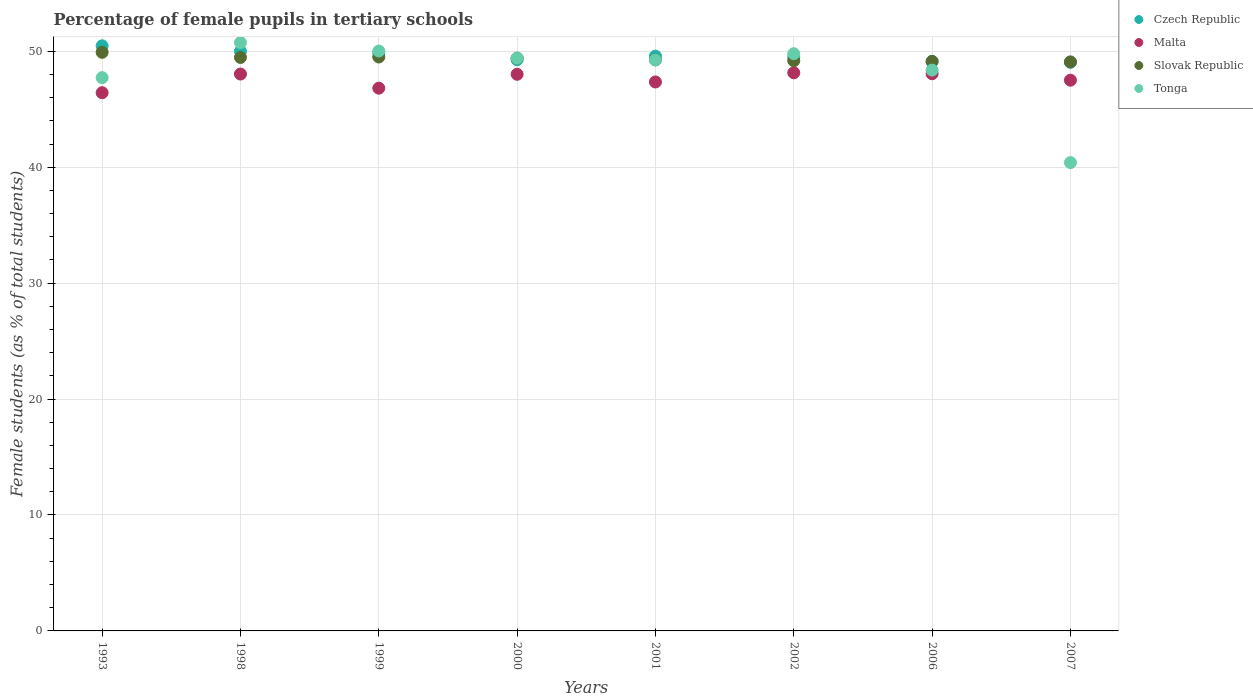How many different coloured dotlines are there?
Provide a short and direct response. 4. What is the percentage of female pupils in tertiary schools in Tonga in 1998?
Provide a short and direct response. 50.75. Across all years, what is the maximum percentage of female pupils in tertiary schools in Slovak Republic?
Keep it short and to the point. 49.91. Across all years, what is the minimum percentage of female pupils in tertiary schools in Malta?
Give a very brief answer. 46.43. In which year was the percentage of female pupils in tertiary schools in Czech Republic maximum?
Offer a very short reply. 1993. In which year was the percentage of female pupils in tertiary schools in Tonga minimum?
Ensure brevity in your answer.  2007. What is the total percentage of female pupils in tertiary schools in Czech Republic in the graph?
Your answer should be very brief. 396.87. What is the difference between the percentage of female pupils in tertiary schools in Tonga in 1999 and that in 2001?
Make the answer very short. 0.77. What is the difference between the percentage of female pupils in tertiary schools in Slovak Republic in 2006 and the percentage of female pupils in tertiary schools in Malta in 2001?
Provide a succinct answer. 1.77. What is the average percentage of female pupils in tertiary schools in Czech Republic per year?
Offer a terse response. 49.61. In the year 2002, what is the difference between the percentage of female pupils in tertiary schools in Tonga and percentage of female pupils in tertiary schools in Slovak Republic?
Provide a short and direct response. 0.6. What is the ratio of the percentage of female pupils in tertiary schools in Tonga in 1998 to that in 2001?
Offer a very short reply. 1.03. Is the difference between the percentage of female pupils in tertiary schools in Tonga in 1993 and 1998 greater than the difference between the percentage of female pupils in tertiary schools in Slovak Republic in 1993 and 1998?
Give a very brief answer. No. What is the difference between the highest and the second highest percentage of female pupils in tertiary schools in Slovak Republic?
Provide a succinct answer. 0.41. What is the difference between the highest and the lowest percentage of female pupils in tertiary schools in Czech Republic?
Offer a very short reply. 1.42. Is the sum of the percentage of female pupils in tertiary schools in Malta in 1993 and 2000 greater than the maximum percentage of female pupils in tertiary schools in Tonga across all years?
Your answer should be compact. Yes. Is it the case that in every year, the sum of the percentage of female pupils in tertiary schools in Czech Republic and percentage of female pupils in tertiary schools in Malta  is greater than the percentage of female pupils in tertiary schools in Tonga?
Offer a very short reply. Yes. Does the percentage of female pupils in tertiary schools in Czech Republic monotonically increase over the years?
Provide a short and direct response. No. Is the percentage of female pupils in tertiary schools in Slovak Republic strictly greater than the percentage of female pupils in tertiary schools in Tonga over the years?
Offer a terse response. No. Is the percentage of female pupils in tertiary schools in Czech Republic strictly less than the percentage of female pupils in tertiary schools in Malta over the years?
Offer a terse response. No. Where does the legend appear in the graph?
Provide a short and direct response. Top right. What is the title of the graph?
Provide a short and direct response. Percentage of female pupils in tertiary schools. What is the label or title of the X-axis?
Ensure brevity in your answer.  Years. What is the label or title of the Y-axis?
Keep it short and to the point. Female students (as % of total students). What is the Female students (as % of total students) of Czech Republic in 1993?
Make the answer very short. 50.47. What is the Female students (as % of total students) in Malta in 1993?
Offer a very short reply. 46.43. What is the Female students (as % of total students) in Slovak Republic in 1993?
Give a very brief answer. 49.91. What is the Female students (as % of total students) of Tonga in 1993?
Your answer should be very brief. 47.72. What is the Female students (as % of total students) in Czech Republic in 1998?
Keep it short and to the point. 50. What is the Female students (as % of total students) of Malta in 1998?
Provide a short and direct response. 48.04. What is the Female students (as % of total students) in Slovak Republic in 1998?
Offer a terse response. 49.47. What is the Female students (as % of total students) in Tonga in 1998?
Your answer should be very brief. 50.75. What is the Female students (as % of total students) of Czech Republic in 1999?
Keep it short and to the point. 49.87. What is the Female students (as % of total students) in Malta in 1999?
Give a very brief answer. 46.82. What is the Female students (as % of total students) of Slovak Republic in 1999?
Offer a terse response. 49.51. What is the Female students (as % of total students) in Tonga in 1999?
Make the answer very short. 50.02. What is the Female students (as % of total students) in Czech Republic in 2000?
Your response must be concise. 49.27. What is the Female students (as % of total students) of Malta in 2000?
Your answer should be compact. 48.02. What is the Female students (as % of total students) in Slovak Republic in 2000?
Your answer should be compact. 49.41. What is the Female students (as % of total students) of Tonga in 2000?
Keep it short and to the point. 49.41. What is the Female students (as % of total students) of Czech Republic in 2001?
Give a very brief answer. 49.58. What is the Female students (as % of total students) in Malta in 2001?
Offer a terse response. 47.35. What is the Female students (as % of total students) of Slovak Republic in 2001?
Keep it short and to the point. 49.27. What is the Female students (as % of total students) of Tonga in 2001?
Your response must be concise. 49.25. What is the Female students (as % of total students) in Czech Republic in 2002?
Offer a terse response. 49.51. What is the Female students (as % of total students) in Malta in 2002?
Provide a succinct answer. 48.15. What is the Female students (as % of total students) in Slovak Republic in 2002?
Offer a very short reply. 49.19. What is the Female students (as % of total students) of Tonga in 2002?
Offer a terse response. 49.79. What is the Female students (as % of total students) in Czech Republic in 2006?
Offer a very short reply. 49.12. What is the Female students (as % of total students) in Malta in 2006?
Your response must be concise. 48.06. What is the Female students (as % of total students) of Slovak Republic in 2006?
Give a very brief answer. 49.12. What is the Female students (as % of total students) in Tonga in 2006?
Make the answer very short. 48.38. What is the Female students (as % of total students) of Czech Republic in 2007?
Your answer should be compact. 49.05. What is the Female students (as % of total students) in Malta in 2007?
Keep it short and to the point. 47.51. What is the Female students (as % of total students) of Slovak Republic in 2007?
Provide a succinct answer. 49.08. What is the Female students (as % of total students) of Tonga in 2007?
Give a very brief answer. 40.4. Across all years, what is the maximum Female students (as % of total students) in Czech Republic?
Your answer should be very brief. 50.47. Across all years, what is the maximum Female students (as % of total students) of Malta?
Ensure brevity in your answer.  48.15. Across all years, what is the maximum Female students (as % of total students) of Slovak Republic?
Keep it short and to the point. 49.91. Across all years, what is the maximum Female students (as % of total students) in Tonga?
Your answer should be very brief. 50.75. Across all years, what is the minimum Female students (as % of total students) in Czech Republic?
Keep it short and to the point. 49.05. Across all years, what is the minimum Female students (as % of total students) in Malta?
Ensure brevity in your answer.  46.43. Across all years, what is the minimum Female students (as % of total students) of Slovak Republic?
Your response must be concise. 49.08. Across all years, what is the minimum Female students (as % of total students) in Tonga?
Ensure brevity in your answer.  40.4. What is the total Female students (as % of total students) of Czech Republic in the graph?
Keep it short and to the point. 396.87. What is the total Female students (as % of total students) of Malta in the graph?
Offer a very short reply. 380.36. What is the total Female students (as % of total students) in Slovak Republic in the graph?
Provide a succinct answer. 394.95. What is the total Female students (as % of total students) in Tonga in the graph?
Your answer should be compact. 385.72. What is the difference between the Female students (as % of total students) in Czech Republic in 1993 and that in 1998?
Keep it short and to the point. 0.47. What is the difference between the Female students (as % of total students) in Malta in 1993 and that in 1998?
Ensure brevity in your answer.  -1.61. What is the difference between the Female students (as % of total students) in Slovak Republic in 1993 and that in 1998?
Offer a very short reply. 0.44. What is the difference between the Female students (as % of total students) of Tonga in 1993 and that in 1998?
Offer a terse response. -3.03. What is the difference between the Female students (as % of total students) in Czech Republic in 1993 and that in 1999?
Give a very brief answer. 0.6. What is the difference between the Female students (as % of total students) of Malta in 1993 and that in 1999?
Ensure brevity in your answer.  -0.39. What is the difference between the Female students (as % of total students) of Slovak Republic in 1993 and that in 1999?
Ensure brevity in your answer.  0.41. What is the difference between the Female students (as % of total students) in Tonga in 1993 and that in 1999?
Provide a succinct answer. -2.3. What is the difference between the Female students (as % of total students) of Czech Republic in 1993 and that in 2000?
Provide a succinct answer. 1.2. What is the difference between the Female students (as % of total students) in Malta in 1993 and that in 2000?
Your response must be concise. -1.59. What is the difference between the Female students (as % of total students) of Slovak Republic in 1993 and that in 2000?
Ensure brevity in your answer.  0.5. What is the difference between the Female students (as % of total students) in Tonga in 1993 and that in 2000?
Provide a succinct answer. -1.68. What is the difference between the Female students (as % of total students) of Czech Republic in 1993 and that in 2001?
Your answer should be compact. 0.89. What is the difference between the Female students (as % of total students) in Malta in 1993 and that in 2001?
Keep it short and to the point. -0.93. What is the difference between the Female students (as % of total students) in Slovak Republic in 1993 and that in 2001?
Your answer should be very brief. 0.64. What is the difference between the Female students (as % of total students) in Tonga in 1993 and that in 2001?
Your answer should be very brief. -1.52. What is the difference between the Female students (as % of total students) in Czech Republic in 1993 and that in 2002?
Make the answer very short. 0.97. What is the difference between the Female students (as % of total students) in Malta in 1993 and that in 2002?
Your answer should be very brief. -1.72. What is the difference between the Female students (as % of total students) of Slovak Republic in 1993 and that in 2002?
Your answer should be very brief. 0.72. What is the difference between the Female students (as % of total students) of Tonga in 1993 and that in 2002?
Give a very brief answer. -2.07. What is the difference between the Female students (as % of total students) of Czech Republic in 1993 and that in 2006?
Give a very brief answer. 1.35. What is the difference between the Female students (as % of total students) in Malta in 1993 and that in 2006?
Make the answer very short. -1.64. What is the difference between the Female students (as % of total students) of Slovak Republic in 1993 and that in 2006?
Your answer should be very brief. 0.79. What is the difference between the Female students (as % of total students) in Tonga in 1993 and that in 2006?
Your response must be concise. -0.65. What is the difference between the Female students (as % of total students) of Czech Republic in 1993 and that in 2007?
Give a very brief answer. 1.42. What is the difference between the Female students (as % of total students) in Malta in 1993 and that in 2007?
Ensure brevity in your answer.  -1.08. What is the difference between the Female students (as % of total students) of Slovak Republic in 1993 and that in 2007?
Offer a very short reply. 0.83. What is the difference between the Female students (as % of total students) of Tonga in 1993 and that in 2007?
Offer a very short reply. 7.33. What is the difference between the Female students (as % of total students) of Czech Republic in 1998 and that in 1999?
Your answer should be compact. 0.13. What is the difference between the Female students (as % of total students) of Malta in 1998 and that in 1999?
Your response must be concise. 1.22. What is the difference between the Female students (as % of total students) in Slovak Republic in 1998 and that in 1999?
Keep it short and to the point. -0.04. What is the difference between the Female students (as % of total students) in Tonga in 1998 and that in 1999?
Your answer should be compact. 0.73. What is the difference between the Female students (as % of total students) of Czech Republic in 1998 and that in 2000?
Offer a terse response. 0.72. What is the difference between the Female students (as % of total students) of Malta in 1998 and that in 2000?
Give a very brief answer. 0.02. What is the difference between the Female students (as % of total students) of Slovak Republic in 1998 and that in 2000?
Your answer should be compact. 0.06. What is the difference between the Female students (as % of total students) in Tonga in 1998 and that in 2000?
Provide a succinct answer. 1.34. What is the difference between the Female students (as % of total students) of Czech Republic in 1998 and that in 2001?
Offer a very short reply. 0.42. What is the difference between the Female students (as % of total students) of Malta in 1998 and that in 2001?
Provide a short and direct response. 0.68. What is the difference between the Female students (as % of total students) of Slovak Republic in 1998 and that in 2001?
Offer a terse response. 0.2. What is the difference between the Female students (as % of total students) of Tonga in 1998 and that in 2001?
Provide a succinct answer. 1.5. What is the difference between the Female students (as % of total students) in Czech Republic in 1998 and that in 2002?
Give a very brief answer. 0.49. What is the difference between the Female students (as % of total students) of Malta in 1998 and that in 2002?
Ensure brevity in your answer.  -0.11. What is the difference between the Female students (as % of total students) of Slovak Republic in 1998 and that in 2002?
Keep it short and to the point. 0.28. What is the difference between the Female students (as % of total students) of Tonga in 1998 and that in 2002?
Offer a very short reply. 0.96. What is the difference between the Female students (as % of total students) of Czech Republic in 1998 and that in 2006?
Give a very brief answer. 0.87. What is the difference between the Female students (as % of total students) of Malta in 1998 and that in 2006?
Offer a very short reply. -0.03. What is the difference between the Female students (as % of total students) in Slovak Republic in 1998 and that in 2006?
Ensure brevity in your answer.  0.34. What is the difference between the Female students (as % of total students) in Tonga in 1998 and that in 2006?
Keep it short and to the point. 2.37. What is the difference between the Female students (as % of total students) of Czech Republic in 1998 and that in 2007?
Ensure brevity in your answer.  0.95. What is the difference between the Female students (as % of total students) in Malta in 1998 and that in 2007?
Make the answer very short. 0.53. What is the difference between the Female students (as % of total students) in Slovak Republic in 1998 and that in 2007?
Offer a very short reply. 0.38. What is the difference between the Female students (as % of total students) in Tonga in 1998 and that in 2007?
Your answer should be compact. 10.35. What is the difference between the Female students (as % of total students) in Czech Republic in 1999 and that in 2000?
Your answer should be compact. 0.59. What is the difference between the Female students (as % of total students) in Malta in 1999 and that in 2000?
Keep it short and to the point. -1.2. What is the difference between the Female students (as % of total students) of Slovak Republic in 1999 and that in 2000?
Make the answer very short. 0.1. What is the difference between the Female students (as % of total students) in Tonga in 1999 and that in 2000?
Offer a terse response. 0.61. What is the difference between the Female students (as % of total students) of Czech Republic in 1999 and that in 2001?
Offer a terse response. 0.29. What is the difference between the Female students (as % of total students) in Malta in 1999 and that in 2001?
Provide a short and direct response. -0.54. What is the difference between the Female students (as % of total students) in Slovak Republic in 1999 and that in 2001?
Keep it short and to the point. 0.24. What is the difference between the Female students (as % of total students) in Tonga in 1999 and that in 2001?
Ensure brevity in your answer.  0.77. What is the difference between the Female students (as % of total students) in Czech Republic in 1999 and that in 2002?
Your response must be concise. 0.36. What is the difference between the Female students (as % of total students) of Malta in 1999 and that in 2002?
Ensure brevity in your answer.  -1.33. What is the difference between the Female students (as % of total students) in Slovak Republic in 1999 and that in 2002?
Keep it short and to the point. 0.32. What is the difference between the Female students (as % of total students) of Tonga in 1999 and that in 2002?
Your response must be concise. 0.23. What is the difference between the Female students (as % of total students) in Czech Republic in 1999 and that in 2006?
Your answer should be compact. 0.74. What is the difference between the Female students (as % of total students) in Malta in 1999 and that in 2006?
Give a very brief answer. -1.24. What is the difference between the Female students (as % of total students) in Slovak Republic in 1999 and that in 2006?
Offer a terse response. 0.38. What is the difference between the Female students (as % of total students) of Tonga in 1999 and that in 2006?
Your answer should be compact. 1.64. What is the difference between the Female students (as % of total students) of Czech Republic in 1999 and that in 2007?
Provide a succinct answer. 0.82. What is the difference between the Female students (as % of total students) of Malta in 1999 and that in 2007?
Make the answer very short. -0.69. What is the difference between the Female students (as % of total students) in Slovak Republic in 1999 and that in 2007?
Your answer should be compact. 0.42. What is the difference between the Female students (as % of total students) of Tonga in 1999 and that in 2007?
Offer a very short reply. 9.62. What is the difference between the Female students (as % of total students) in Czech Republic in 2000 and that in 2001?
Make the answer very short. -0.31. What is the difference between the Female students (as % of total students) in Malta in 2000 and that in 2001?
Offer a very short reply. 0.66. What is the difference between the Female students (as % of total students) of Slovak Republic in 2000 and that in 2001?
Offer a very short reply. 0.14. What is the difference between the Female students (as % of total students) of Tonga in 2000 and that in 2001?
Your answer should be very brief. 0.16. What is the difference between the Female students (as % of total students) of Czech Republic in 2000 and that in 2002?
Your answer should be compact. -0.23. What is the difference between the Female students (as % of total students) of Malta in 2000 and that in 2002?
Your answer should be compact. -0.13. What is the difference between the Female students (as % of total students) of Slovak Republic in 2000 and that in 2002?
Your answer should be very brief. 0.22. What is the difference between the Female students (as % of total students) in Tonga in 2000 and that in 2002?
Offer a very short reply. -0.38. What is the difference between the Female students (as % of total students) in Czech Republic in 2000 and that in 2006?
Keep it short and to the point. 0.15. What is the difference between the Female students (as % of total students) of Malta in 2000 and that in 2006?
Keep it short and to the point. -0.05. What is the difference between the Female students (as % of total students) in Slovak Republic in 2000 and that in 2006?
Make the answer very short. 0.28. What is the difference between the Female students (as % of total students) in Tonga in 2000 and that in 2006?
Provide a succinct answer. 1.03. What is the difference between the Female students (as % of total students) in Czech Republic in 2000 and that in 2007?
Offer a terse response. 0.22. What is the difference between the Female students (as % of total students) of Malta in 2000 and that in 2007?
Make the answer very short. 0.51. What is the difference between the Female students (as % of total students) of Slovak Republic in 2000 and that in 2007?
Ensure brevity in your answer.  0.32. What is the difference between the Female students (as % of total students) of Tonga in 2000 and that in 2007?
Make the answer very short. 9.01. What is the difference between the Female students (as % of total students) in Czech Republic in 2001 and that in 2002?
Give a very brief answer. 0.08. What is the difference between the Female students (as % of total students) of Malta in 2001 and that in 2002?
Give a very brief answer. -0.79. What is the difference between the Female students (as % of total students) in Slovak Republic in 2001 and that in 2002?
Offer a terse response. 0.08. What is the difference between the Female students (as % of total students) of Tonga in 2001 and that in 2002?
Your answer should be very brief. -0.54. What is the difference between the Female students (as % of total students) in Czech Republic in 2001 and that in 2006?
Make the answer very short. 0.46. What is the difference between the Female students (as % of total students) in Malta in 2001 and that in 2006?
Keep it short and to the point. -0.71. What is the difference between the Female students (as % of total students) in Slovak Republic in 2001 and that in 2006?
Offer a terse response. 0.14. What is the difference between the Female students (as % of total students) of Tonga in 2001 and that in 2006?
Keep it short and to the point. 0.87. What is the difference between the Female students (as % of total students) of Czech Republic in 2001 and that in 2007?
Your response must be concise. 0.53. What is the difference between the Female students (as % of total students) of Malta in 2001 and that in 2007?
Your answer should be very brief. -0.15. What is the difference between the Female students (as % of total students) in Slovak Republic in 2001 and that in 2007?
Your answer should be compact. 0.18. What is the difference between the Female students (as % of total students) of Tonga in 2001 and that in 2007?
Keep it short and to the point. 8.85. What is the difference between the Female students (as % of total students) in Czech Republic in 2002 and that in 2006?
Ensure brevity in your answer.  0.38. What is the difference between the Female students (as % of total students) in Malta in 2002 and that in 2006?
Your response must be concise. 0.09. What is the difference between the Female students (as % of total students) in Slovak Republic in 2002 and that in 2006?
Provide a succinct answer. 0.06. What is the difference between the Female students (as % of total students) of Tonga in 2002 and that in 2006?
Ensure brevity in your answer.  1.41. What is the difference between the Female students (as % of total students) in Czech Republic in 2002 and that in 2007?
Offer a very short reply. 0.45. What is the difference between the Female students (as % of total students) of Malta in 2002 and that in 2007?
Give a very brief answer. 0.64. What is the difference between the Female students (as % of total students) in Slovak Republic in 2002 and that in 2007?
Give a very brief answer. 0.1. What is the difference between the Female students (as % of total students) in Tonga in 2002 and that in 2007?
Your response must be concise. 9.39. What is the difference between the Female students (as % of total students) of Czech Republic in 2006 and that in 2007?
Make the answer very short. 0.07. What is the difference between the Female students (as % of total students) in Malta in 2006 and that in 2007?
Provide a short and direct response. 0.56. What is the difference between the Female students (as % of total students) of Slovak Republic in 2006 and that in 2007?
Your answer should be compact. 0.04. What is the difference between the Female students (as % of total students) in Tonga in 2006 and that in 2007?
Keep it short and to the point. 7.98. What is the difference between the Female students (as % of total students) of Czech Republic in 1993 and the Female students (as % of total students) of Malta in 1998?
Give a very brief answer. 2.44. What is the difference between the Female students (as % of total students) of Czech Republic in 1993 and the Female students (as % of total students) of Slovak Republic in 1998?
Provide a short and direct response. 1. What is the difference between the Female students (as % of total students) in Czech Republic in 1993 and the Female students (as % of total students) in Tonga in 1998?
Provide a short and direct response. -0.28. What is the difference between the Female students (as % of total students) of Malta in 1993 and the Female students (as % of total students) of Slovak Republic in 1998?
Ensure brevity in your answer.  -3.04. What is the difference between the Female students (as % of total students) of Malta in 1993 and the Female students (as % of total students) of Tonga in 1998?
Offer a very short reply. -4.32. What is the difference between the Female students (as % of total students) of Slovak Republic in 1993 and the Female students (as % of total students) of Tonga in 1998?
Your answer should be very brief. -0.84. What is the difference between the Female students (as % of total students) in Czech Republic in 1993 and the Female students (as % of total students) in Malta in 1999?
Keep it short and to the point. 3.65. What is the difference between the Female students (as % of total students) in Czech Republic in 1993 and the Female students (as % of total students) in Slovak Republic in 1999?
Make the answer very short. 0.97. What is the difference between the Female students (as % of total students) in Czech Republic in 1993 and the Female students (as % of total students) in Tonga in 1999?
Your answer should be compact. 0.45. What is the difference between the Female students (as % of total students) of Malta in 1993 and the Female students (as % of total students) of Slovak Republic in 1999?
Give a very brief answer. -3.08. What is the difference between the Female students (as % of total students) in Malta in 1993 and the Female students (as % of total students) in Tonga in 1999?
Give a very brief answer. -3.6. What is the difference between the Female students (as % of total students) in Slovak Republic in 1993 and the Female students (as % of total students) in Tonga in 1999?
Make the answer very short. -0.11. What is the difference between the Female students (as % of total students) in Czech Republic in 1993 and the Female students (as % of total students) in Malta in 2000?
Make the answer very short. 2.46. What is the difference between the Female students (as % of total students) of Czech Republic in 1993 and the Female students (as % of total students) of Slovak Republic in 2000?
Provide a succinct answer. 1.06. What is the difference between the Female students (as % of total students) of Czech Republic in 1993 and the Female students (as % of total students) of Tonga in 2000?
Your answer should be very brief. 1.06. What is the difference between the Female students (as % of total students) of Malta in 1993 and the Female students (as % of total students) of Slovak Republic in 2000?
Provide a short and direct response. -2.98. What is the difference between the Female students (as % of total students) of Malta in 1993 and the Female students (as % of total students) of Tonga in 2000?
Your response must be concise. -2.98. What is the difference between the Female students (as % of total students) in Slovak Republic in 1993 and the Female students (as % of total students) in Tonga in 2000?
Offer a very short reply. 0.5. What is the difference between the Female students (as % of total students) of Czech Republic in 1993 and the Female students (as % of total students) of Malta in 2001?
Your response must be concise. 3.12. What is the difference between the Female students (as % of total students) in Czech Republic in 1993 and the Female students (as % of total students) in Slovak Republic in 2001?
Your response must be concise. 1.2. What is the difference between the Female students (as % of total students) in Czech Republic in 1993 and the Female students (as % of total students) in Tonga in 2001?
Provide a short and direct response. 1.22. What is the difference between the Female students (as % of total students) in Malta in 1993 and the Female students (as % of total students) in Slovak Republic in 2001?
Offer a terse response. -2.84. What is the difference between the Female students (as % of total students) in Malta in 1993 and the Female students (as % of total students) in Tonga in 2001?
Give a very brief answer. -2.82. What is the difference between the Female students (as % of total students) in Slovak Republic in 1993 and the Female students (as % of total students) in Tonga in 2001?
Make the answer very short. 0.66. What is the difference between the Female students (as % of total students) of Czech Republic in 1993 and the Female students (as % of total students) of Malta in 2002?
Give a very brief answer. 2.33. What is the difference between the Female students (as % of total students) of Czech Republic in 1993 and the Female students (as % of total students) of Slovak Republic in 2002?
Provide a short and direct response. 1.28. What is the difference between the Female students (as % of total students) in Czech Republic in 1993 and the Female students (as % of total students) in Tonga in 2002?
Give a very brief answer. 0.68. What is the difference between the Female students (as % of total students) in Malta in 1993 and the Female students (as % of total students) in Slovak Republic in 2002?
Keep it short and to the point. -2.76. What is the difference between the Female students (as % of total students) of Malta in 1993 and the Female students (as % of total students) of Tonga in 2002?
Keep it short and to the point. -3.37. What is the difference between the Female students (as % of total students) in Slovak Republic in 1993 and the Female students (as % of total students) in Tonga in 2002?
Your response must be concise. 0.12. What is the difference between the Female students (as % of total students) of Czech Republic in 1993 and the Female students (as % of total students) of Malta in 2006?
Your answer should be compact. 2.41. What is the difference between the Female students (as % of total students) of Czech Republic in 1993 and the Female students (as % of total students) of Slovak Republic in 2006?
Provide a short and direct response. 1.35. What is the difference between the Female students (as % of total students) in Czech Republic in 1993 and the Female students (as % of total students) in Tonga in 2006?
Ensure brevity in your answer.  2.09. What is the difference between the Female students (as % of total students) of Malta in 1993 and the Female students (as % of total students) of Slovak Republic in 2006?
Your answer should be compact. -2.7. What is the difference between the Female students (as % of total students) of Malta in 1993 and the Female students (as % of total students) of Tonga in 2006?
Provide a succinct answer. -1.95. What is the difference between the Female students (as % of total students) of Slovak Republic in 1993 and the Female students (as % of total students) of Tonga in 2006?
Provide a short and direct response. 1.53. What is the difference between the Female students (as % of total students) of Czech Republic in 1993 and the Female students (as % of total students) of Malta in 2007?
Offer a terse response. 2.97. What is the difference between the Female students (as % of total students) of Czech Republic in 1993 and the Female students (as % of total students) of Slovak Republic in 2007?
Your response must be concise. 1.39. What is the difference between the Female students (as % of total students) in Czech Republic in 1993 and the Female students (as % of total students) in Tonga in 2007?
Keep it short and to the point. 10.07. What is the difference between the Female students (as % of total students) of Malta in 1993 and the Female students (as % of total students) of Slovak Republic in 2007?
Offer a very short reply. -2.66. What is the difference between the Female students (as % of total students) of Malta in 1993 and the Female students (as % of total students) of Tonga in 2007?
Make the answer very short. 6.03. What is the difference between the Female students (as % of total students) in Slovak Republic in 1993 and the Female students (as % of total students) in Tonga in 2007?
Offer a very short reply. 9.51. What is the difference between the Female students (as % of total students) in Czech Republic in 1998 and the Female students (as % of total students) in Malta in 1999?
Give a very brief answer. 3.18. What is the difference between the Female students (as % of total students) in Czech Republic in 1998 and the Female students (as % of total students) in Slovak Republic in 1999?
Your answer should be compact. 0.49. What is the difference between the Female students (as % of total students) in Czech Republic in 1998 and the Female students (as % of total students) in Tonga in 1999?
Your response must be concise. -0.02. What is the difference between the Female students (as % of total students) in Malta in 1998 and the Female students (as % of total students) in Slovak Republic in 1999?
Ensure brevity in your answer.  -1.47. What is the difference between the Female students (as % of total students) of Malta in 1998 and the Female students (as % of total students) of Tonga in 1999?
Offer a very short reply. -1.99. What is the difference between the Female students (as % of total students) of Slovak Republic in 1998 and the Female students (as % of total students) of Tonga in 1999?
Offer a very short reply. -0.55. What is the difference between the Female students (as % of total students) of Czech Republic in 1998 and the Female students (as % of total students) of Malta in 2000?
Give a very brief answer. 1.98. What is the difference between the Female students (as % of total students) in Czech Republic in 1998 and the Female students (as % of total students) in Slovak Republic in 2000?
Your answer should be compact. 0.59. What is the difference between the Female students (as % of total students) of Czech Republic in 1998 and the Female students (as % of total students) of Tonga in 2000?
Your answer should be very brief. 0.59. What is the difference between the Female students (as % of total students) in Malta in 1998 and the Female students (as % of total students) in Slovak Republic in 2000?
Provide a succinct answer. -1.37. What is the difference between the Female students (as % of total students) in Malta in 1998 and the Female students (as % of total students) in Tonga in 2000?
Make the answer very short. -1.37. What is the difference between the Female students (as % of total students) in Slovak Republic in 1998 and the Female students (as % of total students) in Tonga in 2000?
Offer a terse response. 0.06. What is the difference between the Female students (as % of total students) in Czech Republic in 1998 and the Female students (as % of total students) in Malta in 2001?
Your response must be concise. 2.64. What is the difference between the Female students (as % of total students) of Czech Republic in 1998 and the Female students (as % of total students) of Slovak Republic in 2001?
Your response must be concise. 0.73. What is the difference between the Female students (as % of total students) of Czech Republic in 1998 and the Female students (as % of total students) of Tonga in 2001?
Your response must be concise. 0.75. What is the difference between the Female students (as % of total students) in Malta in 1998 and the Female students (as % of total students) in Slovak Republic in 2001?
Ensure brevity in your answer.  -1.23. What is the difference between the Female students (as % of total students) of Malta in 1998 and the Female students (as % of total students) of Tonga in 2001?
Ensure brevity in your answer.  -1.21. What is the difference between the Female students (as % of total students) of Slovak Republic in 1998 and the Female students (as % of total students) of Tonga in 2001?
Your response must be concise. 0.22. What is the difference between the Female students (as % of total students) of Czech Republic in 1998 and the Female students (as % of total students) of Malta in 2002?
Ensure brevity in your answer.  1.85. What is the difference between the Female students (as % of total students) in Czech Republic in 1998 and the Female students (as % of total students) in Slovak Republic in 2002?
Keep it short and to the point. 0.81. What is the difference between the Female students (as % of total students) of Czech Republic in 1998 and the Female students (as % of total students) of Tonga in 2002?
Your answer should be very brief. 0.21. What is the difference between the Female students (as % of total students) of Malta in 1998 and the Female students (as % of total students) of Slovak Republic in 2002?
Your answer should be compact. -1.15. What is the difference between the Female students (as % of total students) of Malta in 1998 and the Female students (as % of total students) of Tonga in 2002?
Provide a short and direct response. -1.76. What is the difference between the Female students (as % of total students) of Slovak Republic in 1998 and the Female students (as % of total students) of Tonga in 2002?
Your response must be concise. -0.32. What is the difference between the Female students (as % of total students) in Czech Republic in 1998 and the Female students (as % of total students) in Malta in 2006?
Your answer should be compact. 1.94. What is the difference between the Female students (as % of total students) in Czech Republic in 1998 and the Female students (as % of total students) in Slovak Republic in 2006?
Provide a succinct answer. 0.87. What is the difference between the Female students (as % of total students) in Czech Republic in 1998 and the Female students (as % of total students) in Tonga in 2006?
Offer a very short reply. 1.62. What is the difference between the Female students (as % of total students) in Malta in 1998 and the Female students (as % of total students) in Slovak Republic in 2006?
Your answer should be very brief. -1.09. What is the difference between the Female students (as % of total students) of Malta in 1998 and the Female students (as % of total students) of Tonga in 2006?
Provide a short and direct response. -0.34. What is the difference between the Female students (as % of total students) of Slovak Republic in 1998 and the Female students (as % of total students) of Tonga in 2006?
Ensure brevity in your answer.  1.09. What is the difference between the Female students (as % of total students) of Czech Republic in 1998 and the Female students (as % of total students) of Malta in 2007?
Keep it short and to the point. 2.49. What is the difference between the Female students (as % of total students) in Czech Republic in 1998 and the Female students (as % of total students) in Slovak Republic in 2007?
Your response must be concise. 0.91. What is the difference between the Female students (as % of total students) of Czech Republic in 1998 and the Female students (as % of total students) of Tonga in 2007?
Make the answer very short. 9.6. What is the difference between the Female students (as % of total students) of Malta in 1998 and the Female students (as % of total students) of Slovak Republic in 2007?
Provide a short and direct response. -1.05. What is the difference between the Female students (as % of total students) of Malta in 1998 and the Female students (as % of total students) of Tonga in 2007?
Provide a short and direct response. 7.64. What is the difference between the Female students (as % of total students) of Slovak Republic in 1998 and the Female students (as % of total students) of Tonga in 2007?
Provide a short and direct response. 9.07. What is the difference between the Female students (as % of total students) in Czech Republic in 1999 and the Female students (as % of total students) in Malta in 2000?
Offer a terse response. 1.85. What is the difference between the Female students (as % of total students) of Czech Republic in 1999 and the Female students (as % of total students) of Slovak Republic in 2000?
Your answer should be very brief. 0.46. What is the difference between the Female students (as % of total students) in Czech Republic in 1999 and the Female students (as % of total students) in Tonga in 2000?
Keep it short and to the point. 0.46. What is the difference between the Female students (as % of total students) of Malta in 1999 and the Female students (as % of total students) of Slovak Republic in 2000?
Offer a very short reply. -2.59. What is the difference between the Female students (as % of total students) of Malta in 1999 and the Female students (as % of total students) of Tonga in 2000?
Provide a short and direct response. -2.59. What is the difference between the Female students (as % of total students) in Slovak Republic in 1999 and the Female students (as % of total students) in Tonga in 2000?
Keep it short and to the point. 0.1. What is the difference between the Female students (as % of total students) of Czech Republic in 1999 and the Female students (as % of total students) of Malta in 2001?
Provide a short and direct response. 2.51. What is the difference between the Female students (as % of total students) in Czech Republic in 1999 and the Female students (as % of total students) in Slovak Republic in 2001?
Provide a succinct answer. 0.6. What is the difference between the Female students (as % of total students) in Czech Republic in 1999 and the Female students (as % of total students) in Tonga in 2001?
Ensure brevity in your answer.  0.62. What is the difference between the Female students (as % of total students) of Malta in 1999 and the Female students (as % of total students) of Slovak Republic in 2001?
Make the answer very short. -2.45. What is the difference between the Female students (as % of total students) of Malta in 1999 and the Female students (as % of total students) of Tonga in 2001?
Give a very brief answer. -2.43. What is the difference between the Female students (as % of total students) in Slovak Republic in 1999 and the Female students (as % of total students) in Tonga in 2001?
Provide a succinct answer. 0.26. What is the difference between the Female students (as % of total students) of Czech Republic in 1999 and the Female students (as % of total students) of Malta in 2002?
Keep it short and to the point. 1.72. What is the difference between the Female students (as % of total students) in Czech Republic in 1999 and the Female students (as % of total students) in Slovak Republic in 2002?
Your response must be concise. 0.68. What is the difference between the Female students (as % of total students) in Czech Republic in 1999 and the Female students (as % of total students) in Tonga in 2002?
Your answer should be very brief. 0.08. What is the difference between the Female students (as % of total students) in Malta in 1999 and the Female students (as % of total students) in Slovak Republic in 2002?
Make the answer very short. -2.37. What is the difference between the Female students (as % of total students) of Malta in 1999 and the Female students (as % of total students) of Tonga in 2002?
Make the answer very short. -2.97. What is the difference between the Female students (as % of total students) in Slovak Republic in 1999 and the Female students (as % of total students) in Tonga in 2002?
Provide a short and direct response. -0.29. What is the difference between the Female students (as % of total students) in Czech Republic in 1999 and the Female students (as % of total students) in Malta in 2006?
Ensure brevity in your answer.  1.81. What is the difference between the Female students (as % of total students) of Czech Republic in 1999 and the Female students (as % of total students) of Slovak Republic in 2006?
Your answer should be very brief. 0.74. What is the difference between the Female students (as % of total students) in Czech Republic in 1999 and the Female students (as % of total students) in Tonga in 2006?
Provide a short and direct response. 1.49. What is the difference between the Female students (as % of total students) of Malta in 1999 and the Female students (as % of total students) of Slovak Republic in 2006?
Make the answer very short. -2.31. What is the difference between the Female students (as % of total students) of Malta in 1999 and the Female students (as % of total students) of Tonga in 2006?
Provide a succinct answer. -1.56. What is the difference between the Female students (as % of total students) of Slovak Republic in 1999 and the Female students (as % of total students) of Tonga in 2006?
Your response must be concise. 1.13. What is the difference between the Female students (as % of total students) of Czech Republic in 1999 and the Female students (as % of total students) of Malta in 2007?
Your answer should be compact. 2.36. What is the difference between the Female students (as % of total students) of Czech Republic in 1999 and the Female students (as % of total students) of Slovak Republic in 2007?
Your response must be concise. 0.78. What is the difference between the Female students (as % of total students) in Czech Republic in 1999 and the Female students (as % of total students) in Tonga in 2007?
Provide a succinct answer. 9.47. What is the difference between the Female students (as % of total students) of Malta in 1999 and the Female students (as % of total students) of Slovak Republic in 2007?
Your response must be concise. -2.27. What is the difference between the Female students (as % of total students) of Malta in 1999 and the Female students (as % of total students) of Tonga in 2007?
Offer a terse response. 6.42. What is the difference between the Female students (as % of total students) in Slovak Republic in 1999 and the Female students (as % of total students) in Tonga in 2007?
Your answer should be compact. 9.11. What is the difference between the Female students (as % of total students) of Czech Republic in 2000 and the Female students (as % of total students) of Malta in 2001?
Ensure brevity in your answer.  1.92. What is the difference between the Female students (as % of total students) in Czech Republic in 2000 and the Female students (as % of total students) in Slovak Republic in 2001?
Give a very brief answer. 0.01. What is the difference between the Female students (as % of total students) of Czech Republic in 2000 and the Female students (as % of total students) of Tonga in 2001?
Offer a terse response. 0.03. What is the difference between the Female students (as % of total students) in Malta in 2000 and the Female students (as % of total students) in Slovak Republic in 2001?
Your answer should be compact. -1.25. What is the difference between the Female students (as % of total students) in Malta in 2000 and the Female students (as % of total students) in Tonga in 2001?
Ensure brevity in your answer.  -1.23. What is the difference between the Female students (as % of total students) in Slovak Republic in 2000 and the Female students (as % of total students) in Tonga in 2001?
Your response must be concise. 0.16. What is the difference between the Female students (as % of total students) in Czech Republic in 2000 and the Female students (as % of total students) in Malta in 2002?
Your answer should be very brief. 1.13. What is the difference between the Female students (as % of total students) of Czech Republic in 2000 and the Female students (as % of total students) of Slovak Republic in 2002?
Offer a terse response. 0.09. What is the difference between the Female students (as % of total students) in Czech Republic in 2000 and the Female students (as % of total students) in Tonga in 2002?
Provide a short and direct response. -0.52. What is the difference between the Female students (as % of total students) in Malta in 2000 and the Female students (as % of total students) in Slovak Republic in 2002?
Provide a short and direct response. -1.17. What is the difference between the Female students (as % of total students) in Malta in 2000 and the Female students (as % of total students) in Tonga in 2002?
Offer a terse response. -1.78. What is the difference between the Female students (as % of total students) in Slovak Republic in 2000 and the Female students (as % of total students) in Tonga in 2002?
Offer a very short reply. -0.38. What is the difference between the Female students (as % of total students) in Czech Republic in 2000 and the Female students (as % of total students) in Malta in 2006?
Offer a very short reply. 1.21. What is the difference between the Female students (as % of total students) in Czech Republic in 2000 and the Female students (as % of total students) in Slovak Republic in 2006?
Offer a terse response. 0.15. What is the difference between the Female students (as % of total students) in Czech Republic in 2000 and the Female students (as % of total students) in Tonga in 2006?
Provide a short and direct response. 0.9. What is the difference between the Female students (as % of total students) in Malta in 2000 and the Female students (as % of total students) in Slovak Republic in 2006?
Provide a succinct answer. -1.11. What is the difference between the Female students (as % of total students) in Malta in 2000 and the Female students (as % of total students) in Tonga in 2006?
Your answer should be compact. -0.36. What is the difference between the Female students (as % of total students) in Slovak Republic in 2000 and the Female students (as % of total students) in Tonga in 2006?
Keep it short and to the point. 1.03. What is the difference between the Female students (as % of total students) of Czech Republic in 2000 and the Female students (as % of total students) of Malta in 2007?
Keep it short and to the point. 1.77. What is the difference between the Female students (as % of total students) of Czech Republic in 2000 and the Female students (as % of total students) of Slovak Republic in 2007?
Your answer should be very brief. 0.19. What is the difference between the Female students (as % of total students) of Czech Republic in 2000 and the Female students (as % of total students) of Tonga in 2007?
Your answer should be compact. 8.88. What is the difference between the Female students (as % of total students) in Malta in 2000 and the Female students (as % of total students) in Slovak Republic in 2007?
Offer a terse response. -1.07. What is the difference between the Female students (as % of total students) in Malta in 2000 and the Female students (as % of total students) in Tonga in 2007?
Offer a very short reply. 7.62. What is the difference between the Female students (as % of total students) of Slovak Republic in 2000 and the Female students (as % of total students) of Tonga in 2007?
Ensure brevity in your answer.  9.01. What is the difference between the Female students (as % of total students) of Czech Republic in 2001 and the Female students (as % of total students) of Malta in 2002?
Provide a succinct answer. 1.44. What is the difference between the Female students (as % of total students) of Czech Republic in 2001 and the Female students (as % of total students) of Slovak Republic in 2002?
Ensure brevity in your answer.  0.39. What is the difference between the Female students (as % of total students) of Czech Republic in 2001 and the Female students (as % of total students) of Tonga in 2002?
Your answer should be compact. -0.21. What is the difference between the Female students (as % of total students) in Malta in 2001 and the Female students (as % of total students) in Slovak Republic in 2002?
Offer a terse response. -1.83. What is the difference between the Female students (as % of total students) in Malta in 2001 and the Female students (as % of total students) in Tonga in 2002?
Your answer should be compact. -2.44. What is the difference between the Female students (as % of total students) in Slovak Republic in 2001 and the Female students (as % of total students) in Tonga in 2002?
Provide a succinct answer. -0.52. What is the difference between the Female students (as % of total students) in Czech Republic in 2001 and the Female students (as % of total students) in Malta in 2006?
Give a very brief answer. 1.52. What is the difference between the Female students (as % of total students) of Czech Republic in 2001 and the Female students (as % of total students) of Slovak Republic in 2006?
Your answer should be compact. 0.46. What is the difference between the Female students (as % of total students) in Czech Republic in 2001 and the Female students (as % of total students) in Tonga in 2006?
Your answer should be very brief. 1.2. What is the difference between the Female students (as % of total students) in Malta in 2001 and the Female students (as % of total students) in Slovak Republic in 2006?
Provide a succinct answer. -1.77. What is the difference between the Female students (as % of total students) of Malta in 2001 and the Female students (as % of total students) of Tonga in 2006?
Provide a succinct answer. -1.03. What is the difference between the Female students (as % of total students) in Slovak Republic in 2001 and the Female students (as % of total students) in Tonga in 2006?
Provide a short and direct response. 0.89. What is the difference between the Female students (as % of total students) of Czech Republic in 2001 and the Female students (as % of total students) of Malta in 2007?
Offer a very short reply. 2.08. What is the difference between the Female students (as % of total students) of Czech Republic in 2001 and the Female students (as % of total students) of Slovak Republic in 2007?
Your answer should be very brief. 0.5. What is the difference between the Female students (as % of total students) in Czech Republic in 2001 and the Female students (as % of total students) in Tonga in 2007?
Provide a succinct answer. 9.18. What is the difference between the Female students (as % of total students) of Malta in 2001 and the Female students (as % of total students) of Slovak Republic in 2007?
Provide a short and direct response. -1.73. What is the difference between the Female students (as % of total students) in Malta in 2001 and the Female students (as % of total students) in Tonga in 2007?
Offer a very short reply. 6.96. What is the difference between the Female students (as % of total students) in Slovak Republic in 2001 and the Female students (as % of total students) in Tonga in 2007?
Your response must be concise. 8.87. What is the difference between the Female students (as % of total students) in Czech Republic in 2002 and the Female students (as % of total students) in Malta in 2006?
Provide a short and direct response. 1.45. What is the difference between the Female students (as % of total students) of Czech Republic in 2002 and the Female students (as % of total students) of Slovak Republic in 2006?
Provide a short and direct response. 0.38. What is the difference between the Female students (as % of total students) in Czech Republic in 2002 and the Female students (as % of total students) in Tonga in 2006?
Make the answer very short. 1.13. What is the difference between the Female students (as % of total students) in Malta in 2002 and the Female students (as % of total students) in Slovak Republic in 2006?
Ensure brevity in your answer.  -0.98. What is the difference between the Female students (as % of total students) in Malta in 2002 and the Female students (as % of total students) in Tonga in 2006?
Your answer should be very brief. -0.23. What is the difference between the Female students (as % of total students) of Slovak Republic in 2002 and the Female students (as % of total students) of Tonga in 2006?
Offer a very short reply. 0.81. What is the difference between the Female students (as % of total students) in Czech Republic in 2002 and the Female students (as % of total students) in Malta in 2007?
Your response must be concise. 2. What is the difference between the Female students (as % of total students) in Czech Republic in 2002 and the Female students (as % of total students) in Slovak Republic in 2007?
Make the answer very short. 0.42. What is the difference between the Female students (as % of total students) in Czech Republic in 2002 and the Female students (as % of total students) in Tonga in 2007?
Your answer should be very brief. 9.11. What is the difference between the Female students (as % of total students) of Malta in 2002 and the Female students (as % of total students) of Slovak Republic in 2007?
Ensure brevity in your answer.  -0.94. What is the difference between the Female students (as % of total students) of Malta in 2002 and the Female students (as % of total students) of Tonga in 2007?
Ensure brevity in your answer.  7.75. What is the difference between the Female students (as % of total students) of Slovak Republic in 2002 and the Female students (as % of total students) of Tonga in 2007?
Give a very brief answer. 8.79. What is the difference between the Female students (as % of total students) in Czech Republic in 2006 and the Female students (as % of total students) in Malta in 2007?
Provide a short and direct response. 1.62. What is the difference between the Female students (as % of total students) in Czech Republic in 2006 and the Female students (as % of total students) in Slovak Republic in 2007?
Give a very brief answer. 0.04. What is the difference between the Female students (as % of total students) of Czech Republic in 2006 and the Female students (as % of total students) of Tonga in 2007?
Offer a terse response. 8.73. What is the difference between the Female students (as % of total students) in Malta in 2006 and the Female students (as % of total students) in Slovak Republic in 2007?
Offer a terse response. -1.02. What is the difference between the Female students (as % of total students) in Malta in 2006 and the Female students (as % of total students) in Tonga in 2007?
Offer a very short reply. 7.66. What is the difference between the Female students (as % of total students) of Slovak Republic in 2006 and the Female students (as % of total students) of Tonga in 2007?
Your response must be concise. 8.73. What is the average Female students (as % of total students) in Czech Republic per year?
Offer a very short reply. 49.61. What is the average Female students (as % of total students) of Malta per year?
Make the answer very short. 47.54. What is the average Female students (as % of total students) in Slovak Republic per year?
Make the answer very short. 49.37. What is the average Female students (as % of total students) in Tonga per year?
Offer a terse response. 48.21. In the year 1993, what is the difference between the Female students (as % of total students) in Czech Republic and Female students (as % of total students) in Malta?
Your response must be concise. 4.05. In the year 1993, what is the difference between the Female students (as % of total students) of Czech Republic and Female students (as % of total students) of Slovak Republic?
Give a very brief answer. 0.56. In the year 1993, what is the difference between the Female students (as % of total students) in Czech Republic and Female students (as % of total students) in Tonga?
Keep it short and to the point. 2.75. In the year 1993, what is the difference between the Female students (as % of total students) of Malta and Female students (as % of total students) of Slovak Republic?
Offer a terse response. -3.49. In the year 1993, what is the difference between the Female students (as % of total students) of Malta and Female students (as % of total students) of Tonga?
Your answer should be compact. -1.3. In the year 1993, what is the difference between the Female students (as % of total students) in Slovak Republic and Female students (as % of total students) in Tonga?
Provide a short and direct response. 2.19. In the year 1998, what is the difference between the Female students (as % of total students) of Czech Republic and Female students (as % of total students) of Malta?
Your answer should be very brief. 1.96. In the year 1998, what is the difference between the Female students (as % of total students) in Czech Republic and Female students (as % of total students) in Slovak Republic?
Your answer should be very brief. 0.53. In the year 1998, what is the difference between the Female students (as % of total students) of Czech Republic and Female students (as % of total students) of Tonga?
Offer a terse response. -0.75. In the year 1998, what is the difference between the Female students (as % of total students) in Malta and Female students (as % of total students) in Slovak Republic?
Offer a terse response. -1.43. In the year 1998, what is the difference between the Female students (as % of total students) in Malta and Female students (as % of total students) in Tonga?
Provide a succinct answer. -2.71. In the year 1998, what is the difference between the Female students (as % of total students) in Slovak Republic and Female students (as % of total students) in Tonga?
Provide a short and direct response. -1.28. In the year 1999, what is the difference between the Female students (as % of total students) in Czech Republic and Female students (as % of total students) in Malta?
Keep it short and to the point. 3.05. In the year 1999, what is the difference between the Female students (as % of total students) of Czech Republic and Female students (as % of total students) of Slovak Republic?
Your answer should be very brief. 0.36. In the year 1999, what is the difference between the Female students (as % of total students) of Czech Republic and Female students (as % of total students) of Tonga?
Provide a succinct answer. -0.15. In the year 1999, what is the difference between the Female students (as % of total students) in Malta and Female students (as % of total students) in Slovak Republic?
Keep it short and to the point. -2.69. In the year 1999, what is the difference between the Female students (as % of total students) in Malta and Female students (as % of total students) in Tonga?
Your answer should be very brief. -3.2. In the year 1999, what is the difference between the Female students (as % of total students) in Slovak Republic and Female students (as % of total students) in Tonga?
Keep it short and to the point. -0.52. In the year 2000, what is the difference between the Female students (as % of total students) in Czech Republic and Female students (as % of total students) in Malta?
Ensure brevity in your answer.  1.26. In the year 2000, what is the difference between the Female students (as % of total students) in Czech Republic and Female students (as % of total students) in Slovak Republic?
Provide a short and direct response. -0.13. In the year 2000, what is the difference between the Female students (as % of total students) in Czech Republic and Female students (as % of total students) in Tonga?
Your answer should be compact. -0.13. In the year 2000, what is the difference between the Female students (as % of total students) in Malta and Female students (as % of total students) in Slovak Republic?
Your response must be concise. -1.39. In the year 2000, what is the difference between the Female students (as % of total students) of Malta and Female students (as % of total students) of Tonga?
Your response must be concise. -1.39. In the year 2000, what is the difference between the Female students (as % of total students) in Slovak Republic and Female students (as % of total students) in Tonga?
Your answer should be compact. -0. In the year 2001, what is the difference between the Female students (as % of total students) in Czech Republic and Female students (as % of total students) in Malta?
Ensure brevity in your answer.  2.23. In the year 2001, what is the difference between the Female students (as % of total students) in Czech Republic and Female students (as % of total students) in Slovak Republic?
Your answer should be compact. 0.32. In the year 2001, what is the difference between the Female students (as % of total students) in Czech Republic and Female students (as % of total students) in Tonga?
Ensure brevity in your answer.  0.34. In the year 2001, what is the difference between the Female students (as % of total students) in Malta and Female students (as % of total students) in Slovak Republic?
Provide a short and direct response. -1.91. In the year 2001, what is the difference between the Female students (as % of total students) in Malta and Female students (as % of total students) in Tonga?
Give a very brief answer. -1.89. In the year 2002, what is the difference between the Female students (as % of total students) in Czech Republic and Female students (as % of total students) in Malta?
Offer a very short reply. 1.36. In the year 2002, what is the difference between the Female students (as % of total students) of Czech Republic and Female students (as % of total students) of Slovak Republic?
Give a very brief answer. 0.32. In the year 2002, what is the difference between the Female students (as % of total students) of Czech Republic and Female students (as % of total students) of Tonga?
Your response must be concise. -0.28. In the year 2002, what is the difference between the Female students (as % of total students) in Malta and Female students (as % of total students) in Slovak Republic?
Provide a short and direct response. -1.04. In the year 2002, what is the difference between the Female students (as % of total students) of Malta and Female students (as % of total students) of Tonga?
Ensure brevity in your answer.  -1.65. In the year 2002, what is the difference between the Female students (as % of total students) in Slovak Republic and Female students (as % of total students) in Tonga?
Give a very brief answer. -0.6. In the year 2006, what is the difference between the Female students (as % of total students) in Czech Republic and Female students (as % of total students) in Malta?
Offer a terse response. 1.06. In the year 2006, what is the difference between the Female students (as % of total students) of Czech Republic and Female students (as % of total students) of Slovak Republic?
Offer a very short reply. 0. In the year 2006, what is the difference between the Female students (as % of total students) in Czech Republic and Female students (as % of total students) in Tonga?
Provide a succinct answer. 0.75. In the year 2006, what is the difference between the Female students (as % of total students) of Malta and Female students (as % of total students) of Slovak Republic?
Give a very brief answer. -1.06. In the year 2006, what is the difference between the Female students (as % of total students) in Malta and Female students (as % of total students) in Tonga?
Provide a succinct answer. -0.32. In the year 2006, what is the difference between the Female students (as % of total students) in Slovak Republic and Female students (as % of total students) in Tonga?
Your response must be concise. 0.74. In the year 2007, what is the difference between the Female students (as % of total students) in Czech Republic and Female students (as % of total students) in Malta?
Make the answer very short. 1.55. In the year 2007, what is the difference between the Female students (as % of total students) of Czech Republic and Female students (as % of total students) of Slovak Republic?
Your answer should be compact. -0.03. In the year 2007, what is the difference between the Female students (as % of total students) of Czech Republic and Female students (as % of total students) of Tonga?
Your answer should be very brief. 8.65. In the year 2007, what is the difference between the Female students (as % of total students) in Malta and Female students (as % of total students) in Slovak Republic?
Ensure brevity in your answer.  -1.58. In the year 2007, what is the difference between the Female students (as % of total students) in Malta and Female students (as % of total students) in Tonga?
Ensure brevity in your answer.  7.11. In the year 2007, what is the difference between the Female students (as % of total students) of Slovak Republic and Female students (as % of total students) of Tonga?
Make the answer very short. 8.69. What is the ratio of the Female students (as % of total students) in Czech Republic in 1993 to that in 1998?
Make the answer very short. 1.01. What is the ratio of the Female students (as % of total students) in Malta in 1993 to that in 1998?
Give a very brief answer. 0.97. What is the ratio of the Female students (as % of total students) in Slovak Republic in 1993 to that in 1998?
Provide a succinct answer. 1.01. What is the ratio of the Female students (as % of total students) of Tonga in 1993 to that in 1998?
Provide a short and direct response. 0.94. What is the ratio of the Female students (as % of total students) in Czech Republic in 1993 to that in 1999?
Your response must be concise. 1.01. What is the ratio of the Female students (as % of total students) in Slovak Republic in 1993 to that in 1999?
Ensure brevity in your answer.  1.01. What is the ratio of the Female students (as % of total students) of Tonga in 1993 to that in 1999?
Provide a succinct answer. 0.95. What is the ratio of the Female students (as % of total students) of Czech Republic in 1993 to that in 2000?
Give a very brief answer. 1.02. What is the ratio of the Female students (as % of total students) in Malta in 1993 to that in 2000?
Your answer should be very brief. 0.97. What is the ratio of the Female students (as % of total students) in Slovak Republic in 1993 to that in 2000?
Offer a very short reply. 1.01. What is the ratio of the Female students (as % of total students) in Tonga in 1993 to that in 2000?
Keep it short and to the point. 0.97. What is the ratio of the Female students (as % of total students) in Czech Republic in 1993 to that in 2001?
Keep it short and to the point. 1.02. What is the ratio of the Female students (as % of total students) of Malta in 1993 to that in 2001?
Your response must be concise. 0.98. What is the ratio of the Female students (as % of total students) of Slovak Republic in 1993 to that in 2001?
Offer a terse response. 1.01. What is the ratio of the Female students (as % of total students) of Tonga in 1993 to that in 2001?
Your answer should be very brief. 0.97. What is the ratio of the Female students (as % of total students) of Czech Republic in 1993 to that in 2002?
Keep it short and to the point. 1.02. What is the ratio of the Female students (as % of total students) of Slovak Republic in 1993 to that in 2002?
Your answer should be very brief. 1.01. What is the ratio of the Female students (as % of total students) in Tonga in 1993 to that in 2002?
Your answer should be very brief. 0.96. What is the ratio of the Female students (as % of total students) of Czech Republic in 1993 to that in 2006?
Your answer should be very brief. 1.03. What is the ratio of the Female students (as % of total students) in Tonga in 1993 to that in 2006?
Offer a terse response. 0.99. What is the ratio of the Female students (as % of total students) of Czech Republic in 1993 to that in 2007?
Give a very brief answer. 1.03. What is the ratio of the Female students (as % of total students) in Malta in 1993 to that in 2007?
Provide a succinct answer. 0.98. What is the ratio of the Female students (as % of total students) of Slovak Republic in 1993 to that in 2007?
Provide a succinct answer. 1.02. What is the ratio of the Female students (as % of total students) of Tonga in 1993 to that in 2007?
Your response must be concise. 1.18. What is the ratio of the Female students (as % of total students) of Slovak Republic in 1998 to that in 1999?
Your answer should be very brief. 1. What is the ratio of the Female students (as % of total students) of Tonga in 1998 to that in 1999?
Provide a succinct answer. 1.01. What is the ratio of the Female students (as % of total students) of Czech Republic in 1998 to that in 2000?
Ensure brevity in your answer.  1.01. What is the ratio of the Female students (as % of total students) in Slovak Republic in 1998 to that in 2000?
Offer a terse response. 1. What is the ratio of the Female students (as % of total students) in Tonga in 1998 to that in 2000?
Provide a short and direct response. 1.03. What is the ratio of the Female students (as % of total students) in Czech Republic in 1998 to that in 2001?
Offer a terse response. 1.01. What is the ratio of the Female students (as % of total students) in Malta in 1998 to that in 2001?
Your response must be concise. 1.01. What is the ratio of the Female students (as % of total students) in Tonga in 1998 to that in 2001?
Your answer should be compact. 1.03. What is the ratio of the Female students (as % of total students) in Czech Republic in 1998 to that in 2002?
Your answer should be very brief. 1.01. What is the ratio of the Female students (as % of total students) in Slovak Republic in 1998 to that in 2002?
Give a very brief answer. 1.01. What is the ratio of the Female students (as % of total students) in Tonga in 1998 to that in 2002?
Give a very brief answer. 1.02. What is the ratio of the Female students (as % of total students) in Czech Republic in 1998 to that in 2006?
Offer a very short reply. 1.02. What is the ratio of the Female students (as % of total students) of Malta in 1998 to that in 2006?
Offer a terse response. 1. What is the ratio of the Female students (as % of total students) of Slovak Republic in 1998 to that in 2006?
Offer a terse response. 1.01. What is the ratio of the Female students (as % of total students) of Tonga in 1998 to that in 2006?
Ensure brevity in your answer.  1.05. What is the ratio of the Female students (as % of total students) of Czech Republic in 1998 to that in 2007?
Keep it short and to the point. 1.02. What is the ratio of the Female students (as % of total students) in Malta in 1998 to that in 2007?
Your answer should be compact. 1.01. What is the ratio of the Female students (as % of total students) in Tonga in 1998 to that in 2007?
Give a very brief answer. 1.26. What is the ratio of the Female students (as % of total students) in Malta in 1999 to that in 2000?
Make the answer very short. 0.98. What is the ratio of the Female students (as % of total students) of Slovak Republic in 1999 to that in 2000?
Your answer should be very brief. 1. What is the ratio of the Female students (as % of total students) of Tonga in 1999 to that in 2000?
Provide a succinct answer. 1.01. What is the ratio of the Female students (as % of total students) in Czech Republic in 1999 to that in 2001?
Your answer should be compact. 1.01. What is the ratio of the Female students (as % of total students) in Malta in 1999 to that in 2001?
Your answer should be compact. 0.99. What is the ratio of the Female students (as % of total students) in Slovak Republic in 1999 to that in 2001?
Offer a very short reply. 1. What is the ratio of the Female students (as % of total students) of Tonga in 1999 to that in 2001?
Give a very brief answer. 1.02. What is the ratio of the Female students (as % of total students) in Czech Republic in 1999 to that in 2002?
Make the answer very short. 1.01. What is the ratio of the Female students (as % of total students) of Malta in 1999 to that in 2002?
Ensure brevity in your answer.  0.97. What is the ratio of the Female students (as % of total students) in Slovak Republic in 1999 to that in 2002?
Your response must be concise. 1.01. What is the ratio of the Female students (as % of total students) of Czech Republic in 1999 to that in 2006?
Your answer should be compact. 1.02. What is the ratio of the Female students (as % of total students) of Malta in 1999 to that in 2006?
Ensure brevity in your answer.  0.97. What is the ratio of the Female students (as % of total students) in Tonga in 1999 to that in 2006?
Your answer should be compact. 1.03. What is the ratio of the Female students (as % of total students) of Czech Republic in 1999 to that in 2007?
Your answer should be compact. 1.02. What is the ratio of the Female students (as % of total students) in Malta in 1999 to that in 2007?
Provide a succinct answer. 0.99. What is the ratio of the Female students (as % of total students) of Slovak Republic in 1999 to that in 2007?
Provide a short and direct response. 1.01. What is the ratio of the Female students (as % of total students) of Tonga in 1999 to that in 2007?
Make the answer very short. 1.24. What is the ratio of the Female students (as % of total students) of Malta in 2000 to that in 2001?
Provide a short and direct response. 1.01. What is the ratio of the Female students (as % of total students) of Slovak Republic in 2000 to that in 2001?
Ensure brevity in your answer.  1. What is the ratio of the Female students (as % of total students) in Tonga in 2000 to that in 2001?
Offer a very short reply. 1. What is the ratio of the Female students (as % of total students) of Czech Republic in 2000 to that in 2002?
Ensure brevity in your answer.  1. What is the ratio of the Female students (as % of total students) in Czech Republic in 2000 to that in 2006?
Your answer should be compact. 1. What is the ratio of the Female students (as % of total students) of Tonga in 2000 to that in 2006?
Offer a terse response. 1.02. What is the ratio of the Female students (as % of total students) of Malta in 2000 to that in 2007?
Provide a succinct answer. 1.01. What is the ratio of the Female students (as % of total students) of Slovak Republic in 2000 to that in 2007?
Ensure brevity in your answer.  1.01. What is the ratio of the Female students (as % of total students) of Tonga in 2000 to that in 2007?
Keep it short and to the point. 1.22. What is the ratio of the Female students (as % of total students) in Malta in 2001 to that in 2002?
Ensure brevity in your answer.  0.98. What is the ratio of the Female students (as % of total students) in Slovak Republic in 2001 to that in 2002?
Offer a terse response. 1. What is the ratio of the Female students (as % of total students) of Czech Republic in 2001 to that in 2006?
Your answer should be compact. 1.01. What is the ratio of the Female students (as % of total students) of Tonga in 2001 to that in 2006?
Make the answer very short. 1.02. What is the ratio of the Female students (as % of total students) in Czech Republic in 2001 to that in 2007?
Your response must be concise. 1.01. What is the ratio of the Female students (as % of total students) of Slovak Republic in 2001 to that in 2007?
Ensure brevity in your answer.  1. What is the ratio of the Female students (as % of total students) of Tonga in 2001 to that in 2007?
Offer a terse response. 1.22. What is the ratio of the Female students (as % of total students) in Slovak Republic in 2002 to that in 2006?
Keep it short and to the point. 1. What is the ratio of the Female students (as % of total students) in Tonga in 2002 to that in 2006?
Keep it short and to the point. 1.03. What is the ratio of the Female students (as % of total students) of Czech Republic in 2002 to that in 2007?
Give a very brief answer. 1.01. What is the ratio of the Female students (as % of total students) of Malta in 2002 to that in 2007?
Ensure brevity in your answer.  1.01. What is the ratio of the Female students (as % of total students) in Tonga in 2002 to that in 2007?
Offer a terse response. 1.23. What is the ratio of the Female students (as % of total students) of Malta in 2006 to that in 2007?
Make the answer very short. 1.01. What is the ratio of the Female students (as % of total students) of Slovak Republic in 2006 to that in 2007?
Offer a very short reply. 1. What is the ratio of the Female students (as % of total students) of Tonga in 2006 to that in 2007?
Your response must be concise. 1.2. What is the difference between the highest and the second highest Female students (as % of total students) of Czech Republic?
Offer a terse response. 0.47. What is the difference between the highest and the second highest Female students (as % of total students) of Malta?
Keep it short and to the point. 0.09. What is the difference between the highest and the second highest Female students (as % of total students) of Slovak Republic?
Your answer should be compact. 0.41. What is the difference between the highest and the second highest Female students (as % of total students) in Tonga?
Your response must be concise. 0.73. What is the difference between the highest and the lowest Female students (as % of total students) of Czech Republic?
Ensure brevity in your answer.  1.42. What is the difference between the highest and the lowest Female students (as % of total students) of Malta?
Your answer should be very brief. 1.72. What is the difference between the highest and the lowest Female students (as % of total students) of Slovak Republic?
Provide a short and direct response. 0.83. What is the difference between the highest and the lowest Female students (as % of total students) of Tonga?
Your answer should be compact. 10.35. 